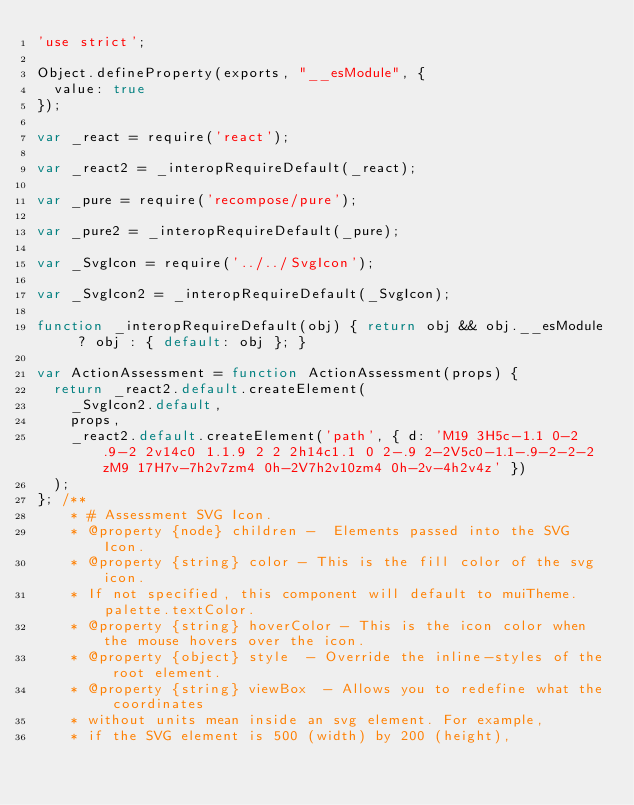<code> <loc_0><loc_0><loc_500><loc_500><_JavaScript_>'use strict';

Object.defineProperty(exports, "__esModule", {
  value: true
});

var _react = require('react');

var _react2 = _interopRequireDefault(_react);

var _pure = require('recompose/pure');

var _pure2 = _interopRequireDefault(_pure);

var _SvgIcon = require('../../SvgIcon');

var _SvgIcon2 = _interopRequireDefault(_SvgIcon);

function _interopRequireDefault(obj) { return obj && obj.__esModule ? obj : { default: obj }; }

var ActionAssessment = function ActionAssessment(props) {
  return _react2.default.createElement(
    _SvgIcon2.default,
    props,
    _react2.default.createElement('path', { d: 'M19 3H5c-1.1 0-2 .9-2 2v14c0 1.1.9 2 2 2h14c1.1 0 2-.9 2-2V5c0-1.1-.9-2-2-2zM9 17H7v-7h2v7zm4 0h-2V7h2v10zm4 0h-2v-4h2v4z' })
  );
}; /** 
    * # Assessment SVG Icon. 
    * @property {node} children -  Elements passed into the SVG Icon.
    * @property {string} color - This is the fill color of the svg icon.
    * If not specified, this component will default to muiTheme.palette.textColor.
    * @property {string} hoverColor - This is the icon color when the mouse hovers over the icon.
    * @property {object} style	- Override the inline-styles of the root element.
    * @property {string} viewBox  - Allows you to redefine what the coordinates
    * without units mean inside an svg element. For example,
    * if the SVG element is 500 (width) by 200 (height),</code> 